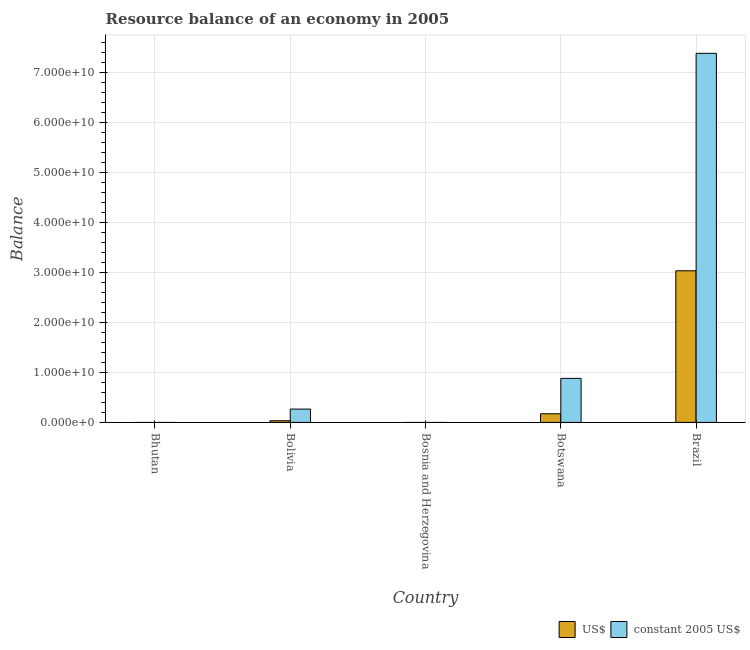How many different coloured bars are there?
Your response must be concise. 2. Are the number of bars per tick equal to the number of legend labels?
Offer a terse response. No. How many bars are there on the 4th tick from the right?
Your answer should be compact. 2. What is the label of the 3rd group of bars from the left?
Make the answer very short. Bosnia and Herzegovina. Across all countries, what is the maximum resource balance in us$?
Provide a short and direct response. 3.03e+1. What is the total resource balance in us$ in the graph?
Keep it short and to the point. 3.24e+1. What is the difference between the resource balance in constant us$ in Botswana and the resource balance in us$ in Bosnia and Herzegovina?
Offer a terse response. 8.80e+09. What is the average resource balance in us$ per country?
Give a very brief answer. 6.47e+09. What is the difference between the resource balance in us$ and resource balance in constant us$ in Brazil?
Provide a succinct answer. -4.35e+1. In how many countries, is the resource balance in us$ greater than 12000000000 units?
Give a very brief answer. 1. What is the ratio of the resource balance in us$ in Bolivia to that in Brazil?
Make the answer very short. 0.01. Is the difference between the resource balance in constant us$ in Bolivia and Botswana greater than the difference between the resource balance in us$ in Bolivia and Botswana?
Give a very brief answer. No. What is the difference between the highest and the second highest resource balance in constant us$?
Give a very brief answer. 6.50e+1. What is the difference between the highest and the lowest resource balance in constant us$?
Your answer should be very brief. 7.38e+1. How many bars are there?
Keep it short and to the point. 6. Are all the bars in the graph horizontal?
Ensure brevity in your answer.  No. Are the values on the major ticks of Y-axis written in scientific E-notation?
Offer a terse response. Yes. Does the graph contain grids?
Offer a very short reply. Yes. Where does the legend appear in the graph?
Your response must be concise. Bottom right. How many legend labels are there?
Your response must be concise. 2. What is the title of the graph?
Your answer should be compact. Resource balance of an economy in 2005. Does "Primary completion rate" appear as one of the legend labels in the graph?
Keep it short and to the point. No. What is the label or title of the X-axis?
Your answer should be compact. Country. What is the label or title of the Y-axis?
Your answer should be compact. Balance. What is the Balance in US$ in Bhutan?
Provide a succinct answer. 0. What is the Balance in US$ in Bolivia?
Offer a very short reply. 3.30e+08. What is the Balance in constant 2005 US$ in Bolivia?
Keep it short and to the point. 2.66e+09. What is the Balance in US$ in Bosnia and Herzegovina?
Make the answer very short. 0. What is the Balance of constant 2005 US$ in Bosnia and Herzegovina?
Provide a short and direct response. 0. What is the Balance in US$ in Botswana?
Offer a very short reply. 1.72e+09. What is the Balance in constant 2005 US$ in Botswana?
Offer a very short reply. 8.80e+09. What is the Balance in US$ in Brazil?
Keep it short and to the point. 3.03e+1. What is the Balance of constant 2005 US$ in Brazil?
Your response must be concise. 7.38e+1. Across all countries, what is the maximum Balance in US$?
Your answer should be very brief. 3.03e+1. Across all countries, what is the maximum Balance of constant 2005 US$?
Your answer should be compact. 7.38e+1. What is the total Balance in US$ in the graph?
Offer a very short reply. 3.24e+1. What is the total Balance in constant 2005 US$ in the graph?
Your response must be concise. 8.52e+1. What is the difference between the Balance in US$ in Bolivia and that in Botswana?
Your answer should be compact. -1.39e+09. What is the difference between the Balance in constant 2005 US$ in Bolivia and that in Botswana?
Provide a short and direct response. -6.14e+09. What is the difference between the Balance in US$ in Bolivia and that in Brazil?
Your answer should be compact. -3.00e+1. What is the difference between the Balance of constant 2005 US$ in Bolivia and that in Brazil?
Your answer should be compact. -7.11e+1. What is the difference between the Balance of US$ in Botswana and that in Brazil?
Your answer should be very brief. -2.86e+1. What is the difference between the Balance of constant 2005 US$ in Botswana and that in Brazil?
Your answer should be compact. -6.50e+1. What is the difference between the Balance in US$ in Bolivia and the Balance in constant 2005 US$ in Botswana?
Make the answer very short. -8.47e+09. What is the difference between the Balance of US$ in Bolivia and the Balance of constant 2005 US$ in Brazil?
Keep it short and to the point. -7.34e+1. What is the difference between the Balance in US$ in Botswana and the Balance in constant 2005 US$ in Brazil?
Give a very brief answer. -7.20e+1. What is the average Balance in US$ per country?
Provide a succinct answer. 6.47e+09. What is the average Balance in constant 2005 US$ per country?
Offer a very short reply. 1.70e+1. What is the difference between the Balance in US$ and Balance in constant 2005 US$ in Bolivia?
Offer a terse response. -2.33e+09. What is the difference between the Balance of US$ and Balance of constant 2005 US$ in Botswana?
Keep it short and to the point. -7.08e+09. What is the difference between the Balance in US$ and Balance in constant 2005 US$ in Brazil?
Offer a very short reply. -4.35e+1. What is the ratio of the Balance in US$ in Bolivia to that in Botswana?
Your answer should be compact. 0.19. What is the ratio of the Balance of constant 2005 US$ in Bolivia to that in Botswana?
Give a very brief answer. 0.3. What is the ratio of the Balance in US$ in Bolivia to that in Brazil?
Your response must be concise. 0.01. What is the ratio of the Balance of constant 2005 US$ in Bolivia to that in Brazil?
Give a very brief answer. 0.04. What is the ratio of the Balance in US$ in Botswana to that in Brazil?
Provide a succinct answer. 0.06. What is the ratio of the Balance of constant 2005 US$ in Botswana to that in Brazil?
Your answer should be compact. 0.12. What is the difference between the highest and the second highest Balance in US$?
Give a very brief answer. 2.86e+1. What is the difference between the highest and the second highest Balance in constant 2005 US$?
Ensure brevity in your answer.  6.50e+1. What is the difference between the highest and the lowest Balance of US$?
Provide a short and direct response. 3.03e+1. What is the difference between the highest and the lowest Balance of constant 2005 US$?
Keep it short and to the point. 7.38e+1. 